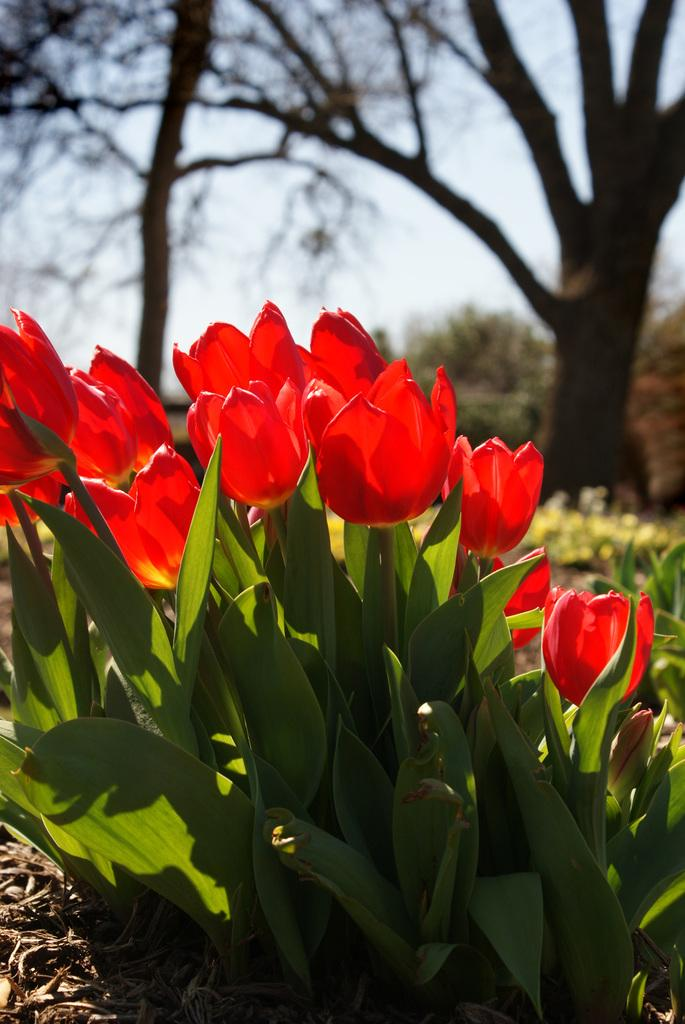What type of vegetation is visible in front of the image? There are plants and flowers in front of the image. What type of vegetation is visible in the background of the image? There are trees in the background of the image. What is visible at the top of the image? The sky is visible at the top of the image. What type of jam is spread on the trees in the background of the image? There is no jam present in the image; it features plants, flowers, trees, and the sky. How does the time of day affect the appearance of the plants and flowers in the image? The provided facts do not mention the time of day, so it is impossible to determine how it might affect the appearance of the plants and flowers in the image. 